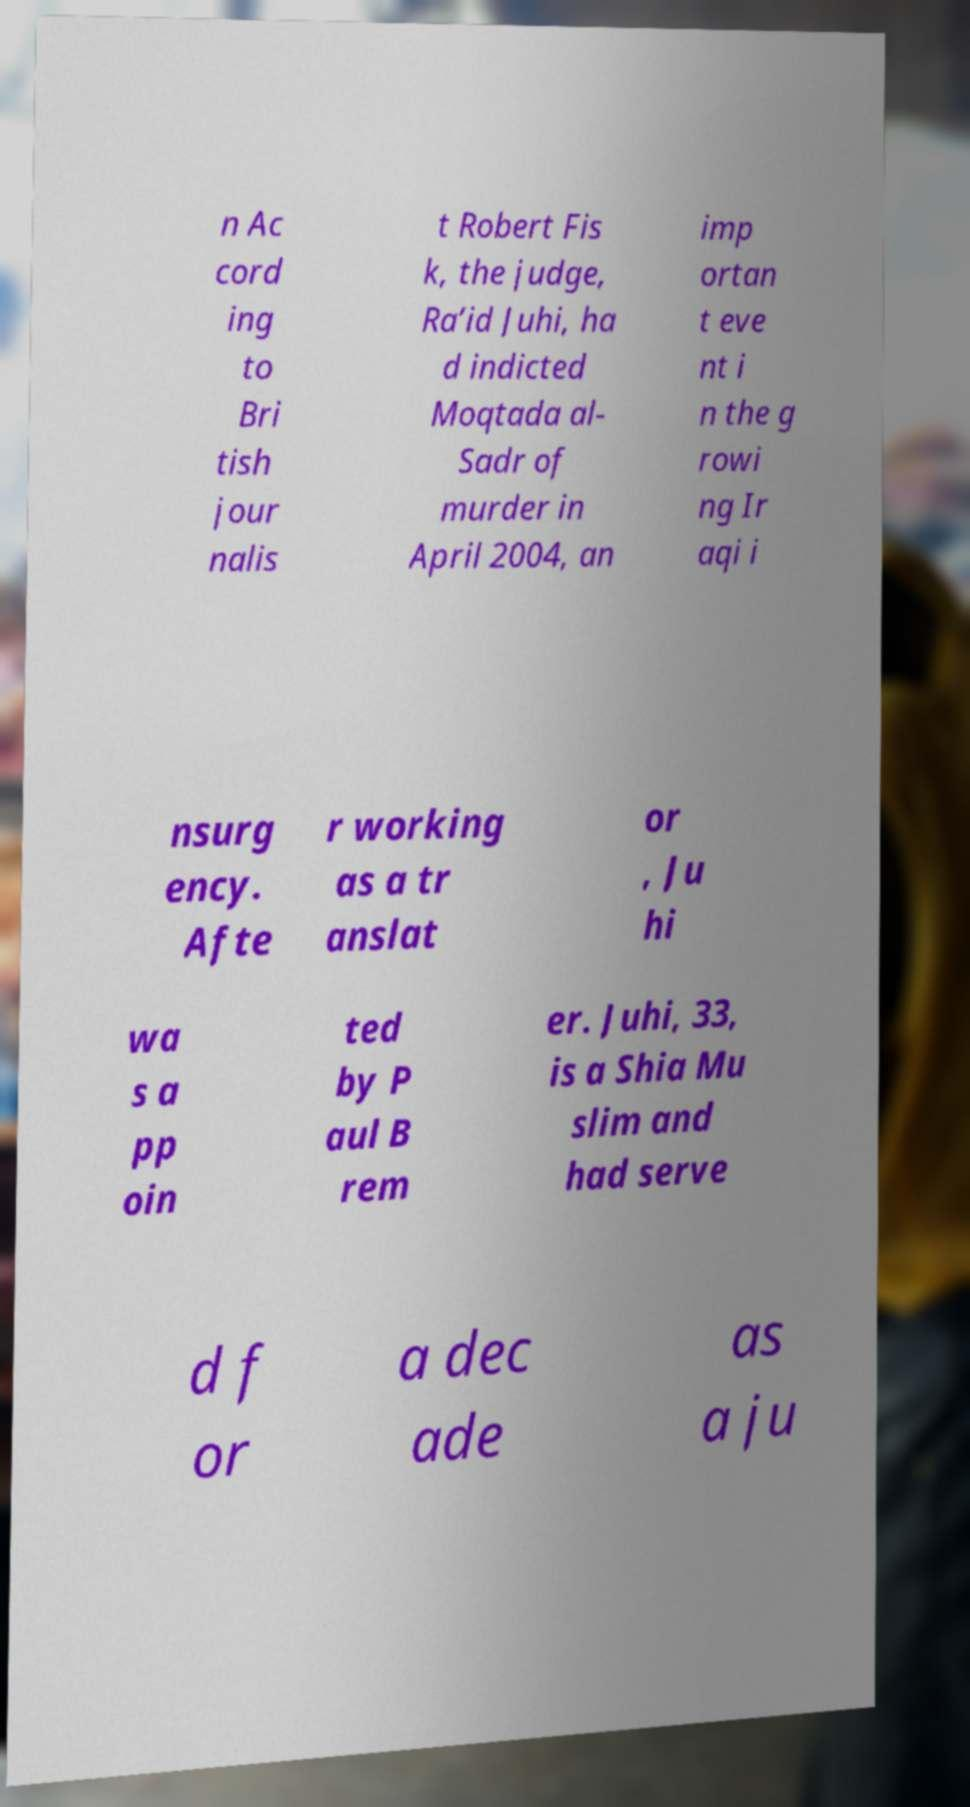Please identify and transcribe the text found in this image. n Ac cord ing to Bri tish jour nalis t Robert Fis k, the judge, Ra’id Juhi, ha d indicted Moqtada al- Sadr of murder in April 2004, an imp ortan t eve nt i n the g rowi ng Ir aqi i nsurg ency. Afte r working as a tr anslat or , Ju hi wa s a pp oin ted by P aul B rem er. Juhi, 33, is a Shia Mu slim and had serve d f or a dec ade as a ju 